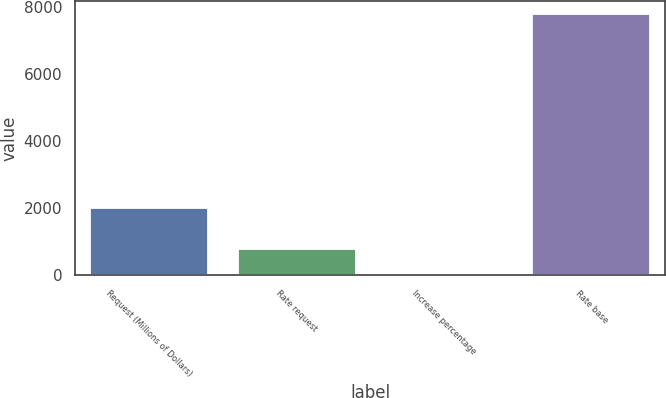Convert chart to OTSL. <chart><loc_0><loc_0><loc_500><loc_500><bar_chart><fcel>Request (Millions of Dollars)<fcel>Rate request<fcel>Increase percentage<fcel>Rate base<nl><fcel>2016<fcel>785.76<fcel>6.4<fcel>7800<nl></chart> 